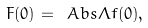Convert formula to latex. <formula><loc_0><loc_0><loc_500><loc_500>F ( 0 ) = \ A b s { \Lambda } f ( 0 ) ,</formula> 